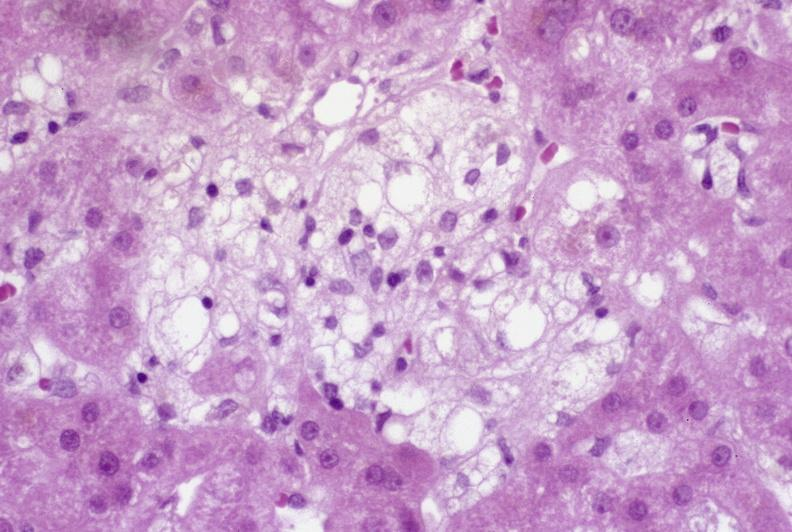s right side atresia present?
Answer the question using a single word or phrase. No 